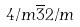Convert formula to latex. <formula><loc_0><loc_0><loc_500><loc_500>4 / m \overline { 3 } 2 / m</formula> 